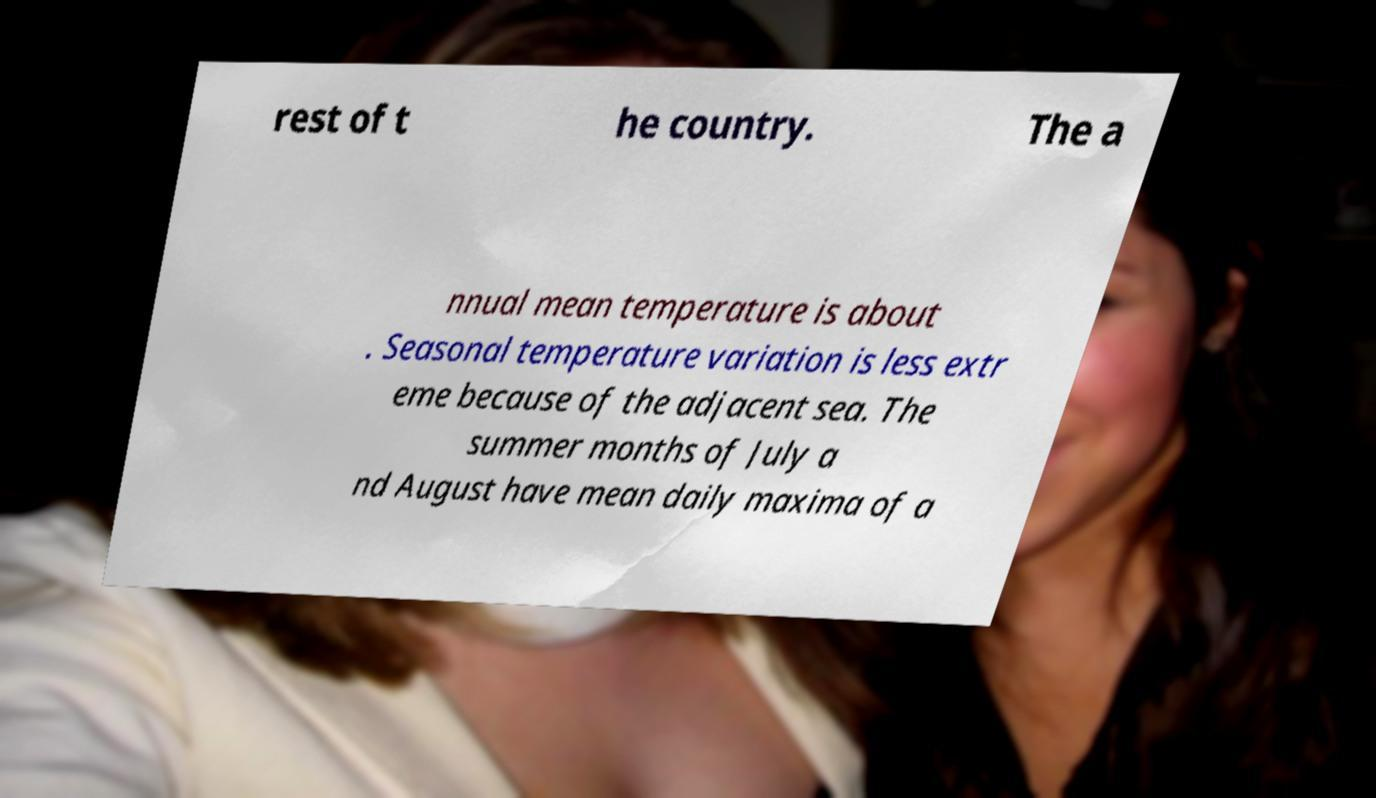Please read and relay the text visible in this image. What does it say? rest of t he country. The a nnual mean temperature is about . Seasonal temperature variation is less extr eme because of the adjacent sea. The summer months of July a nd August have mean daily maxima of a 